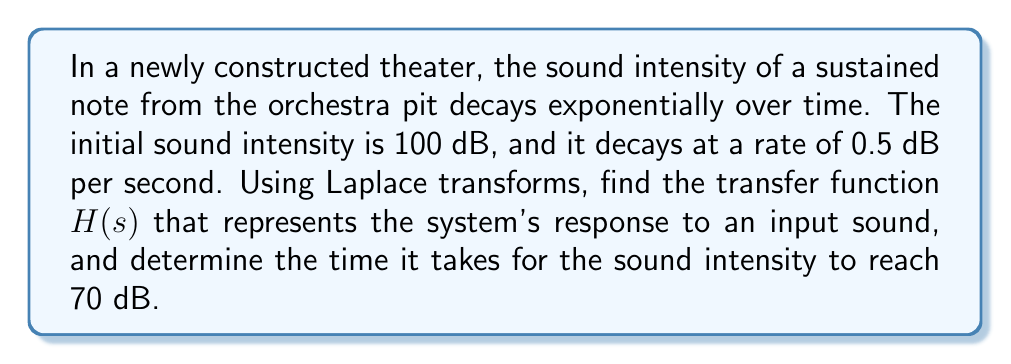Give your solution to this math problem. Let's approach this problem step-by-step using Laplace transforms:

1) First, we need to model the sound decay. The sound intensity $I(t)$ can be expressed as:

   $$I(t) = 100e^{-0.5t}$$

   where $t$ is time in seconds.

2) To find the transfer function, we need to take the Laplace transform of this equation:

   $$\mathcal{L}\{I(t)\} = \mathcal{L}\{100e^{-0.5t}\}$$

3) Using the Laplace transform property for exponential functions:

   $$\mathcal{L}\{ae^{-bt}\} = \frac{a}{s+b}$$

   We get:

   $$I(s) = \frac{100}{s+0.5}$$

4) The transfer function $H(s)$ is defined as the ratio of output to input in the s-domain. Assuming a unit step input (sustained note), the input in the s-domain is $1/s$. Therefore:

   $$H(s) = \frac{I(s)}{1/s} = \frac{100s}{s+0.5}$$

5) To find the time it takes for the sound intensity to reach 70 dB, we need to solve:

   $$70 = 100e^{-0.5t}$$

6) Taking natural logarithms of both sides:

   $$\ln(0.7) = -0.5t$$

7) Solving for $t$:

   $$t = -\frac{2\ln(0.7)}{1} \approx 0.7133 \text{ seconds}$$
Answer: The transfer function is $H(s) = \frac{100s}{s+0.5}$, and it takes approximately 0.7133 seconds for the sound intensity to decay to 70 dB. 